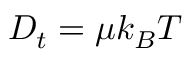Convert formula to latex. <formula><loc_0><loc_0><loc_500><loc_500>D _ { t } = \mu k _ { B } T</formula> 